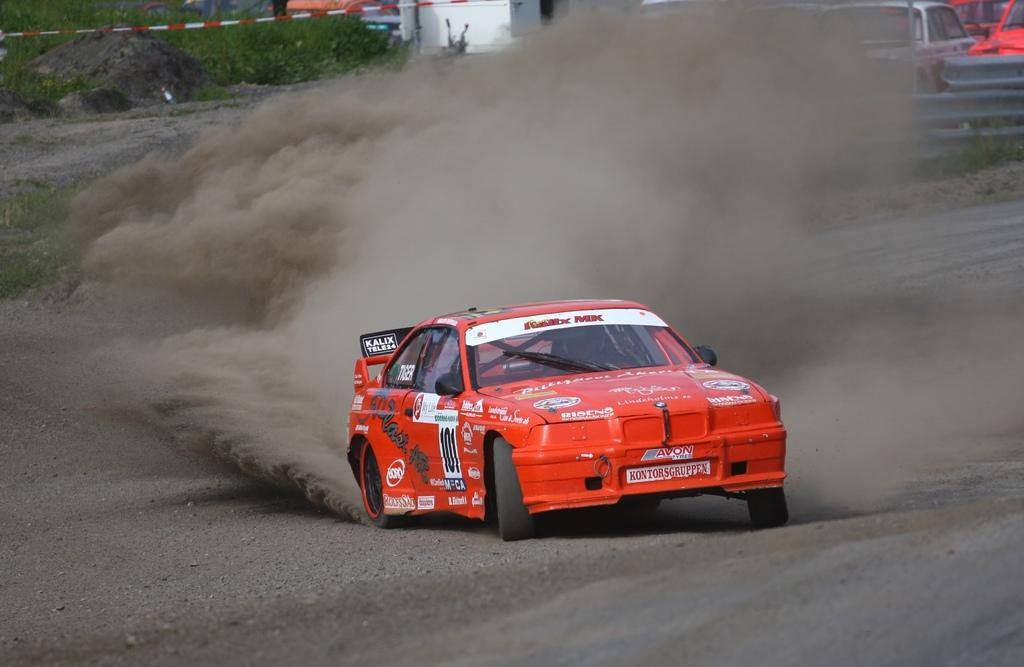What is happening to the vehicle in the image? Dust is coming out from a vehicle in the image. What else can be seen in the background of the image? There are vehicles and a rock in the background of the image. What type of vegetation is present in the background of the image? There is grass in the background of the image. What type of stew is being prepared on the rock in the image? There is no stew or cooking activity present in the image; it only shows a vehicle with dust coming out and other elements in the background. 